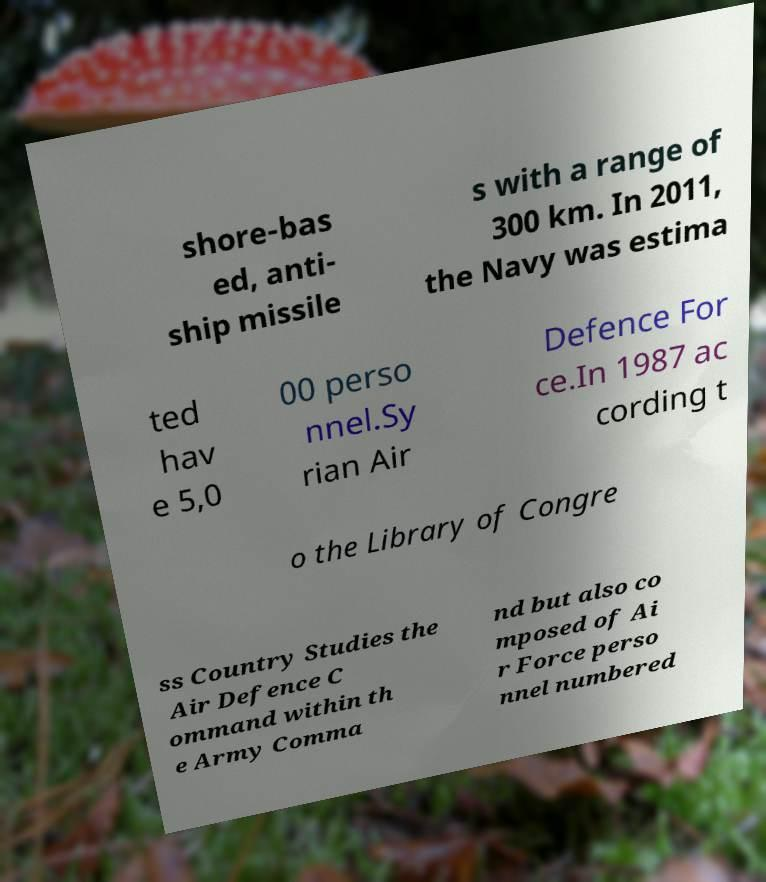For documentation purposes, I need the text within this image transcribed. Could you provide that? shore-bas ed, anti- ship missile s with a range of 300 km. In 2011, the Navy was estima ted hav e 5,0 00 perso nnel.Sy rian Air Defence For ce.In 1987 ac cording t o the Library of Congre ss Country Studies the Air Defence C ommand within th e Army Comma nd but also co mposed of Ai r Force perso nnel numbered 